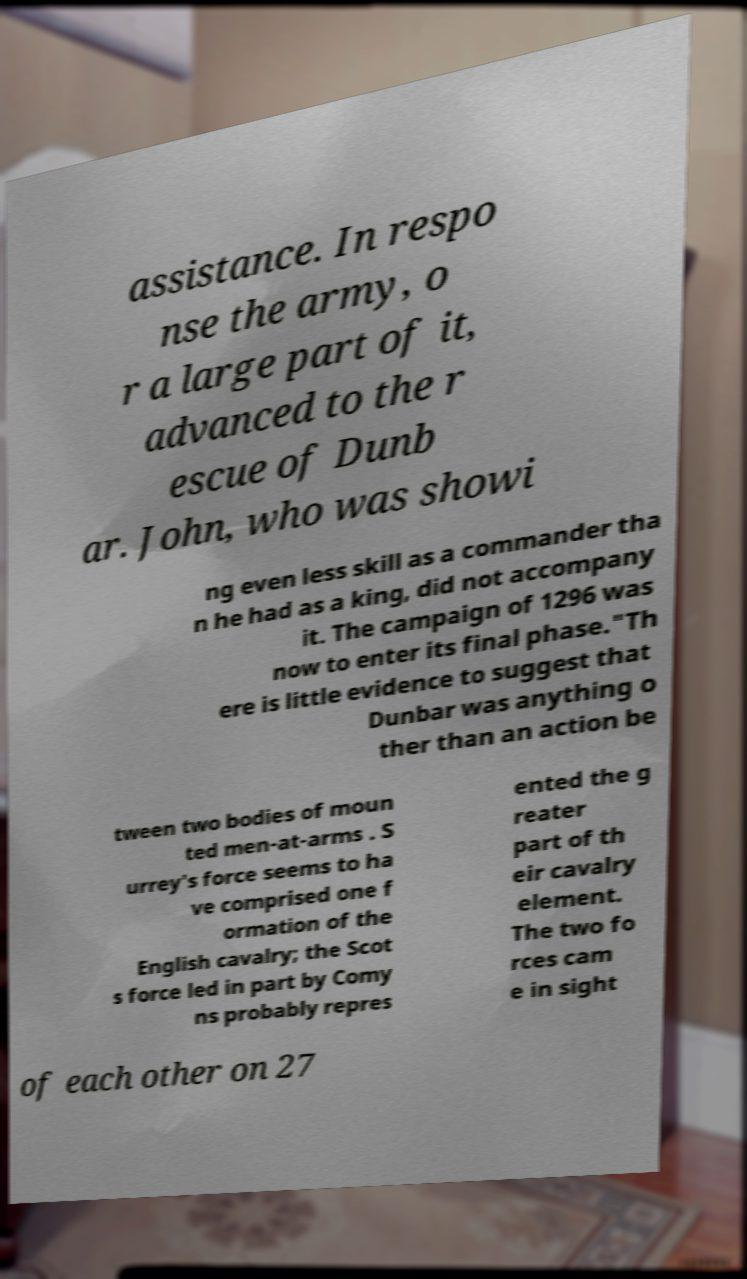Can you accurately transcribe the text from the provided image for me? assistance. In respo nse the army, o r a large part of it, advanced to the r escue of Dunb ar. John, who was showi ng even less skill as a commander tha n he had as a king, did not accompany it. The campaign of 1296 was now to enter its final phase."Th ere is little evidence to suggest that Dunbar was anything o ther than an action be tween two bodies of moun ted men-at-arms . S urrey's force seems to ha ve comprised one f ormation of the English cavalry; the Scot s force led in part by Comy ns probably repres ented the g reater part of th eir cavalry element. The two fo rces cam e in sight of each other on 27 